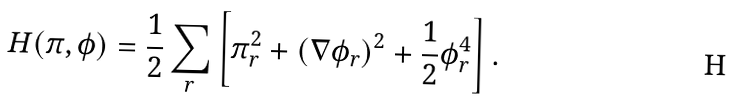<formula> <loc_0><loc_0><loc_500><loc_500>H ( \pi , \phi ) = \frac { 1 } { 2 } \sum _ { r } \left [ \pi _ { r } ^ { 2 } + \left ( \nabla \phi _ { r } \right ) ^ { 2 } + \frac { 1 } { 2 } \phi _ { r } ^ { 4 } \right ] .</formula> 